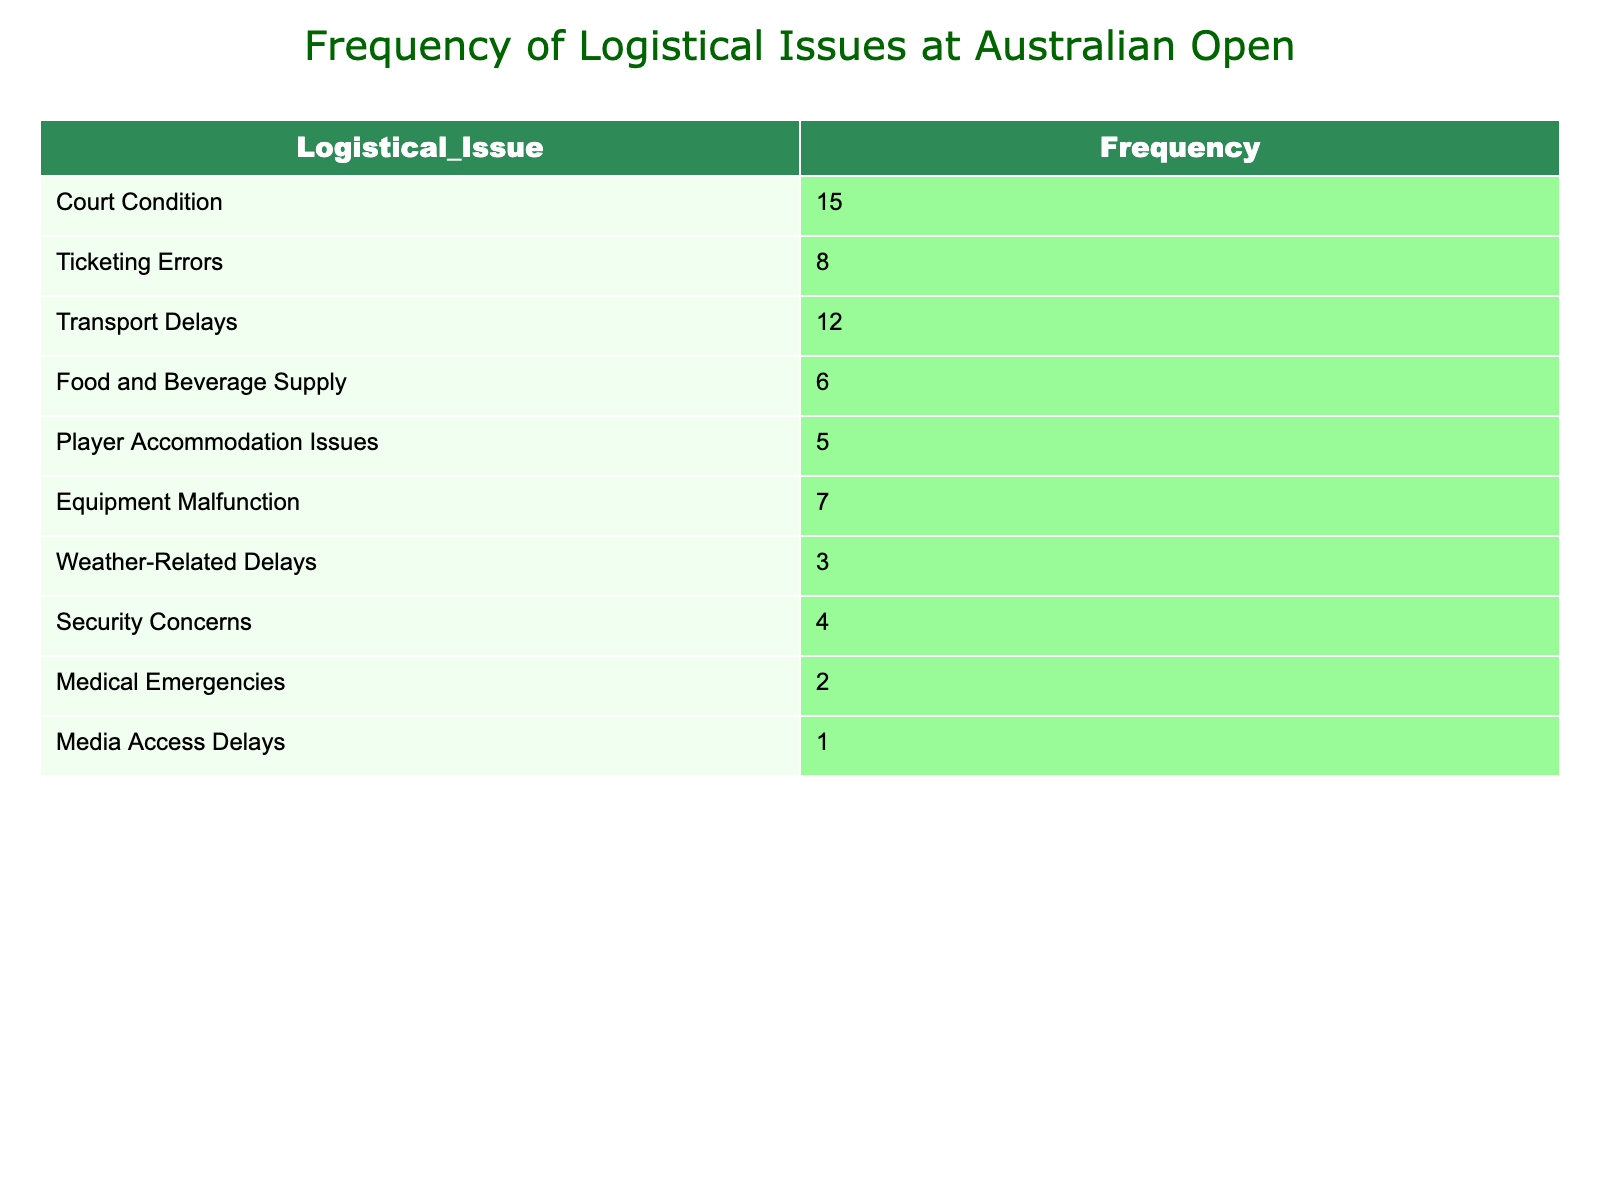What is the most frequently reported logistical issue at the Australian Open? The table shows that "Court Condition" has the highest frequency with a count of 15, making it the most frequently reported logistical issue.
Answer: Court Condition How many more reports were there for Transport Delays than for Security Concerns? The frequency of Transport Delays is 12, while the frequency of Security Concerns is 4. Subtracting these gives 12 - 4 = 8.
Answer: 8 What percentage of the total reported logistical issues are related to Food and Beverage Supply? First, we sum all frequencies: 15 + 8 + 12 + 6 + 5 + 7 + 3 + 4 + 2 + 1 = 63. Food and Beverage Supply frequency is 6. To find the percentage, we calculate (6 / 63) * 100 = 9.52%.
Answer: 9.52% Is it true that Medical Emergencies were reported more frequently than Security Concerns? The frequency of Medical Emergencies is 2, and the frequency of Security Concerns is 4. Since 2 is less than 4, the statement is false.
Answer: No What is the total frequency of logistical issues that are not related to weather? The frequencies for weather-related delays (3) should be excluded. Summing the remaining frequencies gives: 15 + 8 + 12 + 6 + 5 + 7 + 4 + 2 + 1 = 60.
Answer: 60 